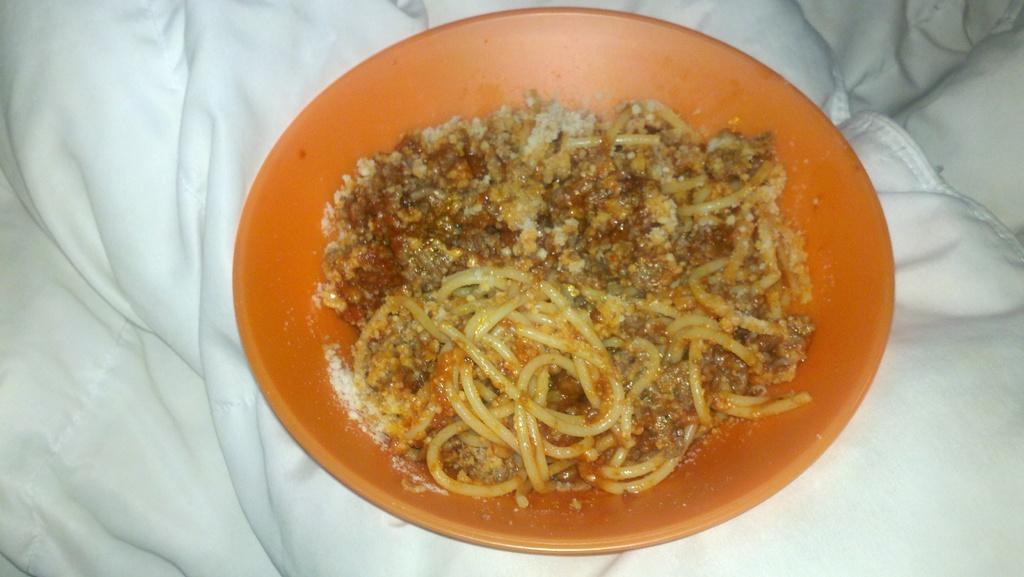Please provide a concise description of this image. On this surface we can see an orange bowl with food. 